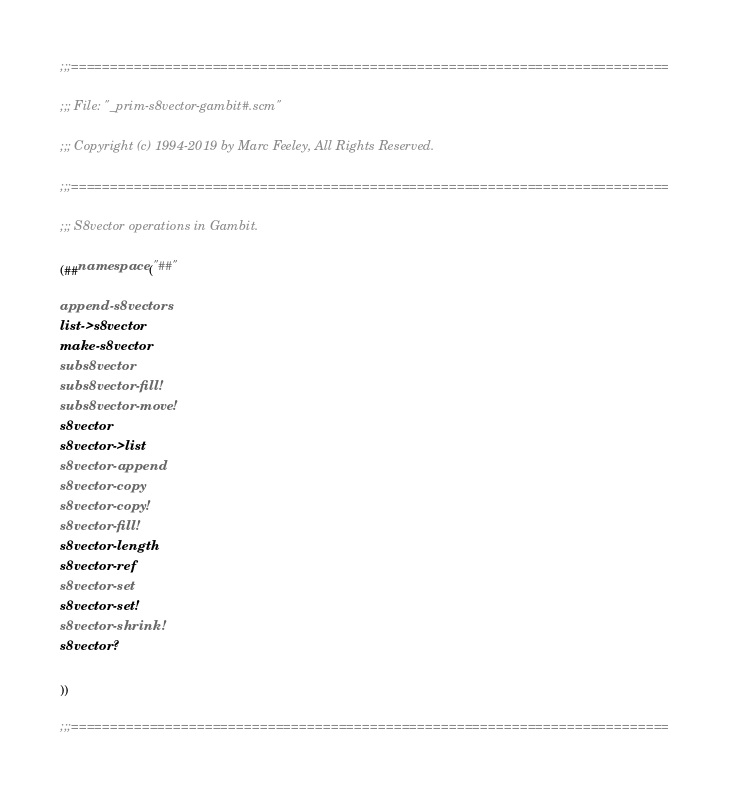<code> <loc_0><loc_0><loc_500><loc_500><_Scheme_>;;;============================================================================

;;; File: "_prim-s8vector-gambit#.scm"

;;; Copyright (c) 1994-2019 by Marc Feeley, All Rights Reserved.

;;;============================================================================

;;; S8vector operations in Gambit.

(##namespace ("##"

append-s8vectors
list->s8vector
make-s8vector
subs8vector
subs8vector-fill!
subs8vector-move!
s8vector
s8vector->list
s8vector-append
s8vector-copy
s8vector-copy!
s8vector-fill!
s8vector-length
s8vector-ref
s8vector-set
s8vector-set!
s8vector-shrink!
s8vector?

))

;;;============================================================================
</code> 